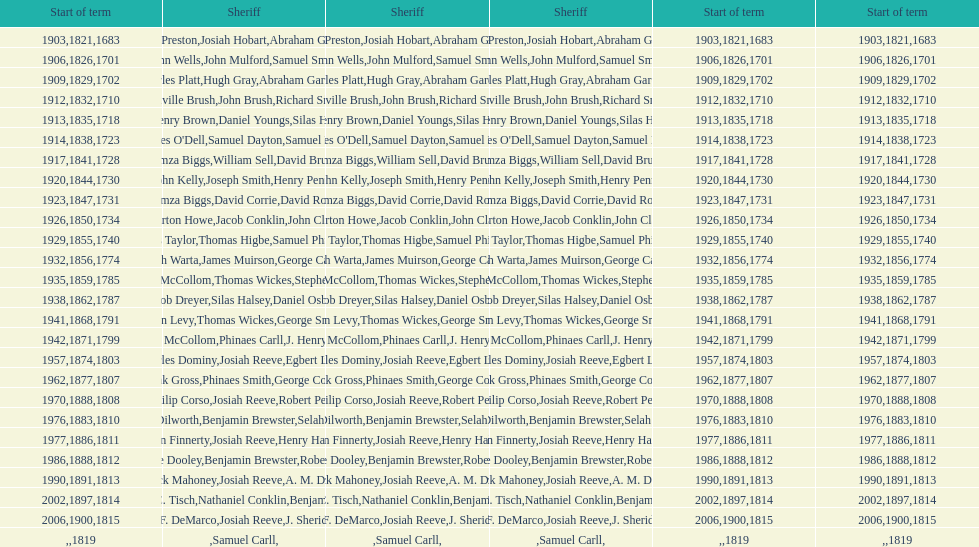What is the number of sheriff's with the last name smith? 5. 